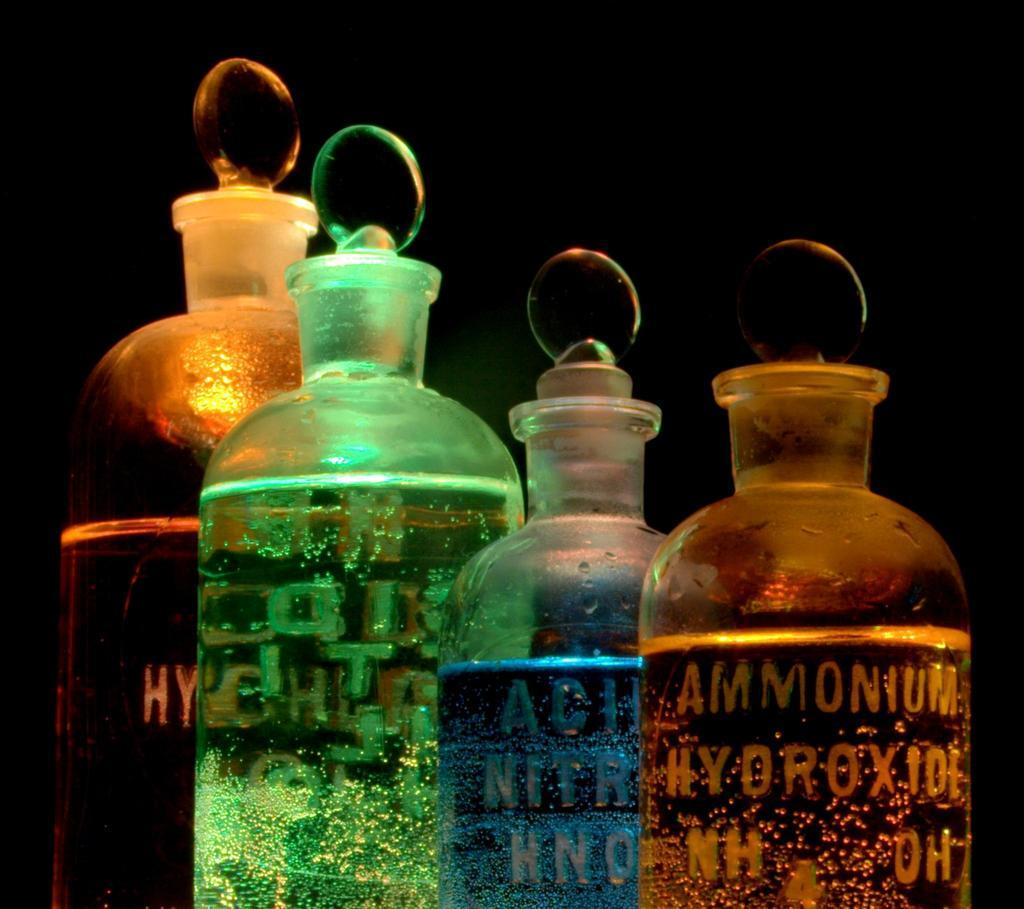<image>
Write a terse but informative summary of the picture. Four glass bottles with a brown Ammonium Hyopoxide in front 